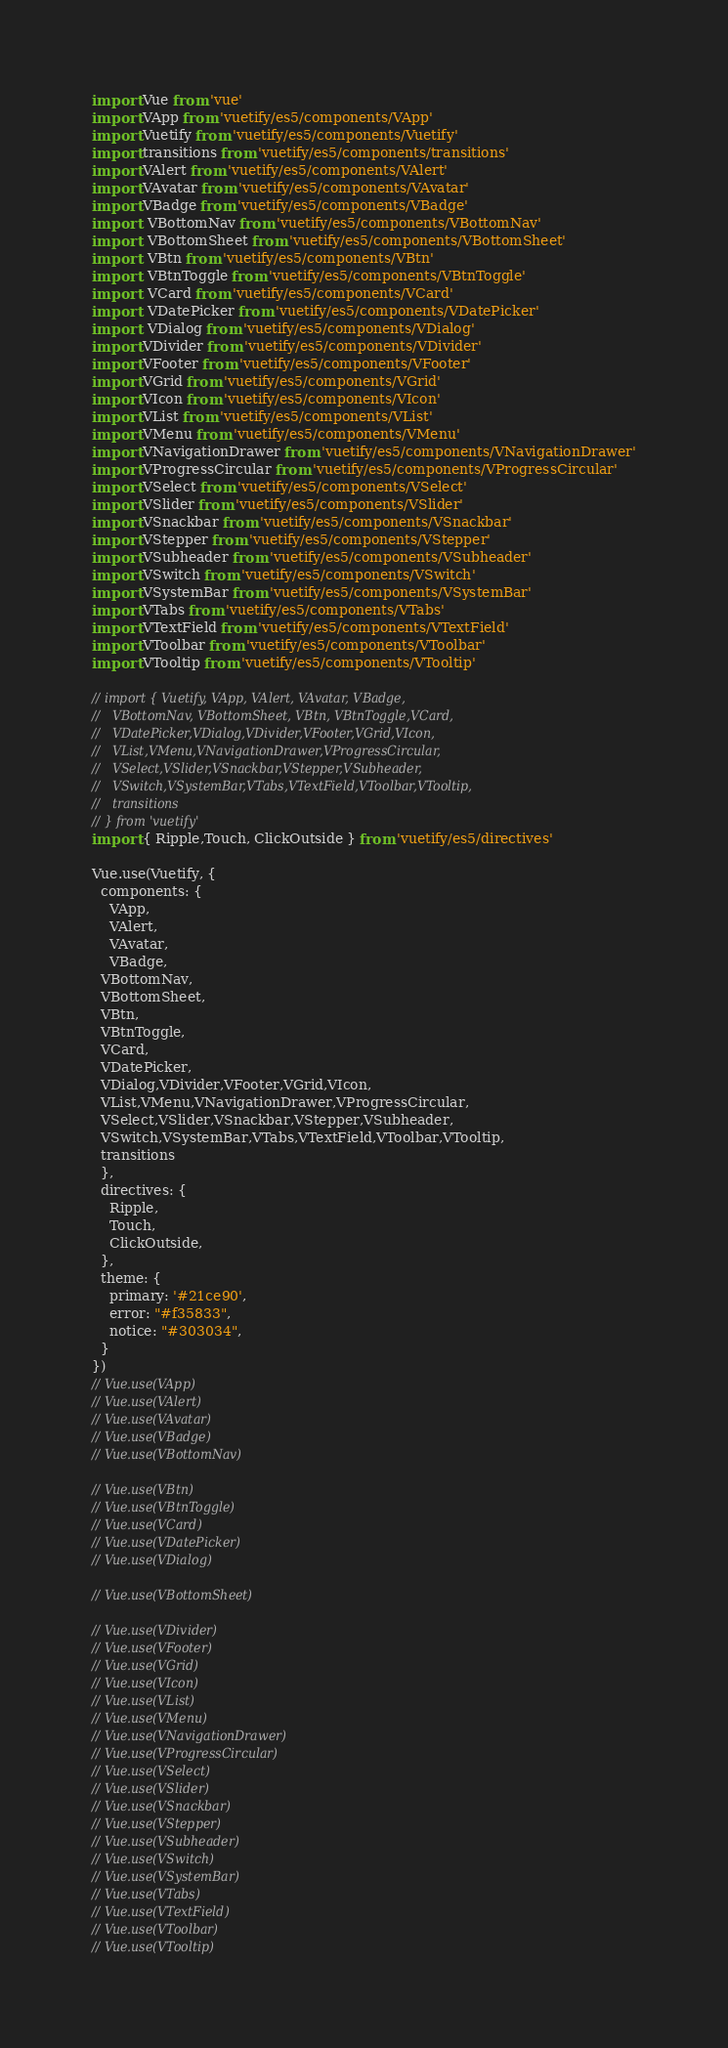Convert code to text. <code><loc_0><loc_0><loc_500><loc_500><_JavaScript_>import Vue from 'vue'
import VApp from 'vuetify/es5/components/VApp'
import Vuetify from 'vuetify/es5/components/Vuetify'
import transitions from 'vuetify/es5/components/transitions'
import VAlert from 'vuetify/es5/components/VAlert' 
import VAvatar from 'vuetify/es5/components/VAvatar' 
import VBadge from 'vuetify/es5/components/VBadge' 
import  VBottomNav from 'vuetify/es5/components/VBottomNav' 
import  VBottomSheet from 'vuetify/es5/components/VBottomSheet' 
import  VBtn from 'vuetify/es5/components/VBtn' 
import  VBtnToggle from 'vuetify/es5/components/VBtnToggle'
import  VCard from 'vuetify/es5/components/VCard'
import  VDatePicker from 'vuetify/es5/components/VDatePicker'
import  VDialog from 'vuetify/es5/components/VDialog'
import VDivider from 'vuetify/es5/components/VDivider'
import VFooter from 'vuetify/es5/components/VFooter'
import VGrid from 'vuetify/es5/components/VGrid'
import VIcon from 'vuetify/es5/components/VIcon'
import VList from 'vuetify/es5/components/VList'
import VMenu from 'vuetify/es5/components/VMenu'
import VNavigationDrawer from 'vuetify/es5/components/VNavigationDrawer'
import VProgressCircular from 'vuetify/es5/components/VProgressCircular'
import VSelect from 'vuetify/es5/components/VSelect'
import VSlider from 'vuetify/es5/components/VSlider'
import VSnackbar from 'vuetify/es5/components/VSnackbar'
import VStepper from 'vuetify/es5/components/VStepper'
import VSubheader from 'vuetify/es5/components/VSubheader'
import VSwitch from 'vuetify/es5/components/VSwitch'
import VSystemBar from 'vuetify/es5/components/VSystemBar'
import VTabs from 'vuetify/es5/components/VTabs'
import VTextField from 'vuetify/es5/components/VTextField'
import VToolbar from 'vuetify/es5/components/VToolbar'
import VTooltip from 'vuetify/es5/components/VTooltip'

// import { Vuetify, VApp, VAlert, VAvatar, VBadge, 
//   VBottomNav, VBottomSheet, VBtn, VBtnToggle,VCard,
//   VDatePicker,VDialog,VDivider,VFooter,VGrid,VIcon,
//   VList,VMenu,VNavigationDrawer,VProgressCircular,
//   VSelect,VSlider,VSnackbar,VStepper,VSubheader,
//   VSwitch,VSystemBar,VTabs,VTextField,VToolbar,VTooltip,
//   transitions
// } from 'vuetify'
import { Ripple,Touch, ClickOutside } from 'vuetify/es5/directives'

Vue.use(Vuetify, {
  components: {
    VApp, 
    VAlert, 
    VAvatar, 
    VBadge, 
  VBottomNav, 
  VBottomSheet, 
  VBtn, 
  VBtnToggle,
  VCard,
  VDatePicker,
  VDialog,VDivider,VFooter,VGrid,VIcon,
  VList,VMenu,VNavigationDrawer,VProgressCircular,
  VSelect,VSlider,VSnackbar,VStepper,VSubheader,
  VSwitch,VSystemBar,VTabs,VTextField,VToolbar,VTooltip,
  transitions
  },
  directives: {
    Ripple,
    Touch,
    ClickOutside,
  },
  theme: {
    primary: '#21ce90',
    error: "#f35833",
    notice: "#303034",
  }
})
// Vue.use(VApp)
// Vue.use(VAlert)
// Vue.use(VAvatar)
// Vue.use(VBadge)
// Vue.use(VBottomNav)

// Vue.use(VBtn)
// Vue.use(VBtnToggle)
// Vue.use(VCard)
// Vue.use(VDatePicker)
// Vue.use(VDialog)

// Vue.use(VBottomSheet)

// Vue.use(VDivider)
// Vue.use(VFooter)
// Vue.use(VGrid)
// Vue.use(VIcon)
// Vue.use(VList)
// Vue.use(VMenu)
// Vue.use(VNavigationDrawer)
// Vue.use(VProgressCircular)
// Vue.use(VSelect)
// Vue.use(VSlider)
// Vue.use(VSnackbar)
// Vue.use(VStepper)
// Vue.use(VSubheader)
// Vue.use(VSwitch)
// Vue.use(VSystemBar)
// Vue.use(VTabs)
// Vue.use(VTextField)
// Vue.use(VToolbar)
// Vue.use(VTooltip)
</code> 